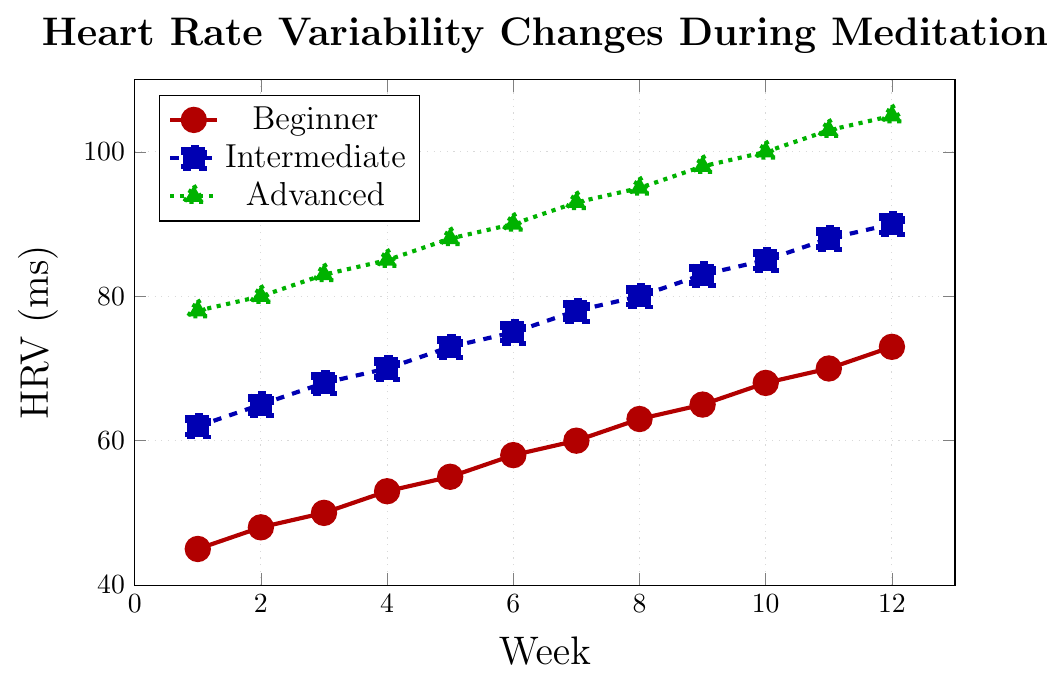What is the initial HRV value for the Advanced group in Week 1? The initial HRV value for the Advanced group can be observed from the point corresponding to Week 1 on the green dotted line with triangle markers. The y-coordinate of this point for Week 1 is 78 ms.
Answer: 78 ms How much has the Beginner group's HRV increased by Week 12? To find the increase in the Beginner group's HRV from Week 1 to Week 12, subtract the initial HRV value at Week 1 (45 ms) from the final HRV value at Week 12 (73 ms). The increase is 73 ms - 45 ms.
Answer: 28 ms Which group shows the highest HRV in Week 8? Observing the data points for each group at Week 8, the Advanced group's HRV value is the highest at 95 ms, compared to 80 ms for Intermediate and 63 ms for Beginner.
Answer: Advanced group What is the average HRV of the Intermediate group at weeks 4, 8, and 12? To find the average HRV at Weeks 4, 8, and 12 for the Intermediate group, sum the HRV values at those weeks and divide by the number of weeks.
The HRV values are 70 ms (Week 4), 80 ms (Week 8), and 90 ms (Week 12). The sum is 70 + 80 + 90 = 240 ms, and the average is 240 / 3.
Answer: 80 ms Compare the overall trend of HRV from Week 1 to Week 12 for all three groups. Which group shows the steepest increase? To compare the trends, calculate the total increase in HRV for each group over the 12 weeks. 
For the Beginner group, the increase is 73 ms - 45 ms = 28 ms. 
For the Intermediate group, it is 90 ms - 62 ms = 28 ms. 
For the Advanced group, it is 105 ms - 78 ms = 27 ms. All groups show a similarly steep increase, but the Beginner and Intermediate groups have an increase of 28 ms, which is slightly higher than the Advanced group at 27 ms.
Answer: Beginner and Intermediate groups At Week 6, what is the difference in HRV between the Advanced and Beginner groups? To find the difference in HRV between the Advanced and Beginner groups at Week 6, subtract the Beginner group's value (58 ms) from the Advanced group's value (90 ms). The difference is 90 ms - 58 ms.
Answer: 32 ms 